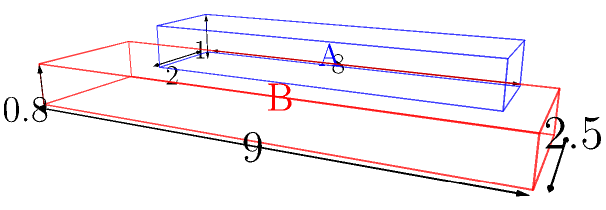As a sports journalist covering pickleball, you're researching equipment specifications. Two pickleball paddle manufacturers have sent you samples of their latest models, represented as rectangular prisms in the diagram. Paddle A has dimensions of $2 \times 8 \times 1$ inches, while Paddle B measures $2.5 \times 9 \times 0.8$ inches. What is the difference in volume between Paddle B and Paddle A, expressed as a percentage of Paddle A's volume? Round your answer to the nearest whole percent. Let's approach this step-by-step:

1) First, calculate the volume of Paddle A:
   $V_A = 2 \times 8 \times 1 = 16$ cubic inches

2) Now, calculate the volume of Paddle B:
   $V_B = 2.5 \times 9 \times 0.8 = 18$ cubic inches

3) Find the difference in volume:
   $\Delta V = V_B - V_A = 18 - 16 = 2$ cubic inches

4) To express this as a percentage of Paddle A's volume:
   $\text{Percentage difference} = \frac{\Delta V}{V_A} \times 100\%$
   $= \frac{2}{16} \times 100\% = 0.125 \times 100\% = 12.5\%$

5) Rounding to the nearest whole percent:
   $12.5\%$ rounds to $13\%$

Therefore, Paddle B's volume is approximately 13% larger than Paddle A's volume.
Answer: 13% 